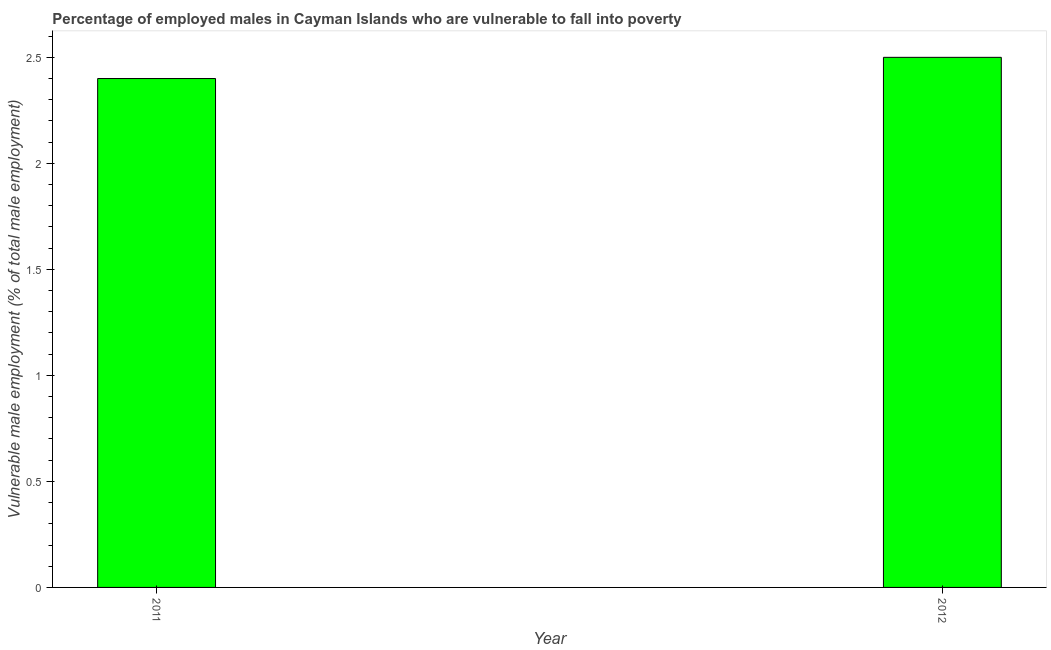Does the graph contain any zero values?
Make the answer very short. No. Does the graph contain grids?
Keep it short and to the point. No. What is the title of the graph?
Your response must be concise. Percentage of employed males in Cayman Islands who are vulnerable to fall into poverty. What is the label or title of the X-axis?
Make the answer very short. Year. What is the label or title of the Y-axis?
Provide a succinct answer. Vulnerable male employment (% of total male employment). What is the percentage of employed males who are vulnerable to fall into poverty in 2011?
Your answer should be compact. 2.4. Across all years, what is the maximum percentage of employed males who are vulnerable to fall into poverty?
Ensure brevity in your answer.  2.5. Across all years, what is the minimum percentage of employed males who are vulnerable to fall into poverty?
Offer a terse response. 2.4. In which year was the percentage of employed males who are vulnerable to fall into poverty maximum?
Offer a terse response. 2012. What is the sum of the percentage of employed males who are vulnerable to fall into poverty?
Provide a succinct answer. 4.9. What is the difference between the percentage of employed males who are vulnerable to fall into poverty in 2011 and 2012?
Make the answer very short. -0.1. What is the average percentage of employed males who are vulnerable to fall into poverty per year?
Your answer should be compact. 2.45. What is the median percentage of employed males who are vulnerable to fall into poverty?
Your answer should be compact. 2.45. What is the ratio of the percentage of employed males who are vulnerable to fall into poverty in 2011 to that in 2012?
Provide a short and direct response. 0.96. In how many years, is the percentage of employed males who are vulnerable to fall into poverty greater than the average percentage of employed males who are vulnerable to fall into poverty taken over all years?
Ensure brevity in your answer.  1. How many bars are there?
Offer a terse response. 2. Are all the bars in the graph horizontal?
Your answer should be very brief. No. What is the difference between two consecutive major ticks on the Y-axis?
Keep it short and to the point. 0.5. What is the Vulnerable male employment (% of total male employment) of 2011?
Your answer should be compact. 2.4. What is the Vulnerable male employment (% of total male employment) in 2012?
Offer a very short reply. 2.5. What is the difference between the Vulnerable male employment (% of total male employment) in 2011 and 2012?
Ensure brevity in your answer.  -0.1. What is the ratio of the Vulnerable male employment (% of total male employment) in 2011 to that in 2012?
Make the answer very short. 0.96. 